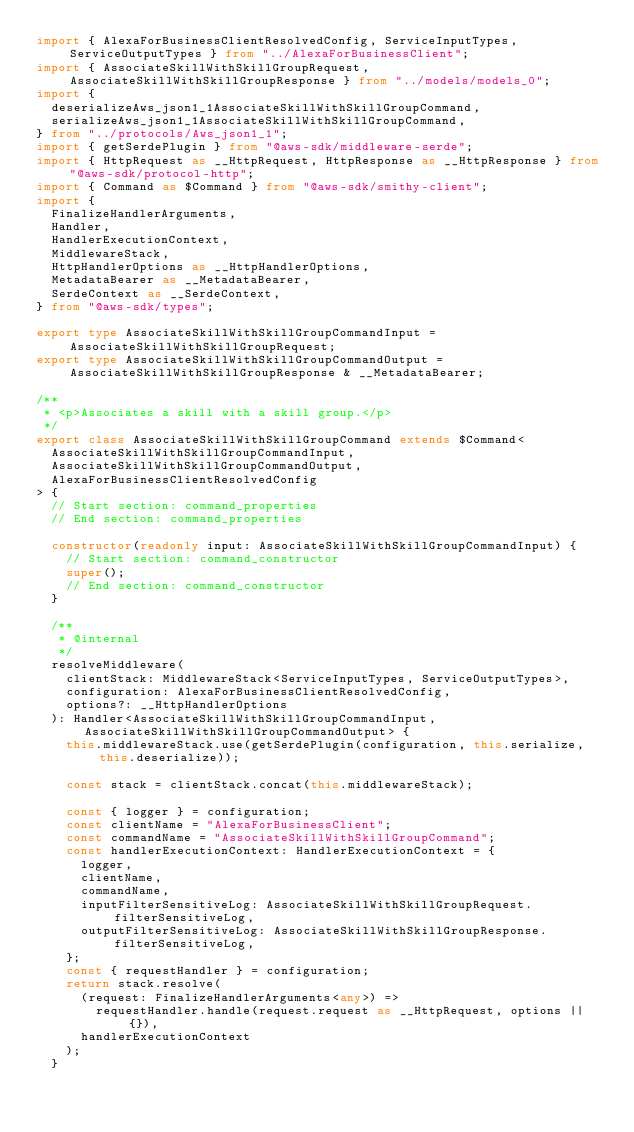Convert code to text. <code><loc_0><loc_0><loc_500><loc_500><_TypeScript_>import { AlexaForBusinessClientResolvedConfig, ServiceInputTypes, ServiceOutputTypes } from "../AlexaForBusinessClient";
import { AssociateSkillWithSkillGroupRequest, AssociateSkillWithSkillGroupResponse } from "../models/models_0";
import {
  deserializeAws_json1_1AssociateSkillWithSkillGroupCommand,
  serializeAws_json1_1AssociateSkillWithSkillGroupCommand,
} from "../protocols/Aws_json1_1";
import { getSerdePlugin } from "@aws-sdk/middleware-serde";
import { HttpRequest as __HttpRequest, HttpResponse as __HttpResponse } from "@aws-sdk/protocol-http";
import { Command as $Command } from "@aws-sdk/smithy-client";
import {
  FinalizeHandlerArguments,
  Handler,
  HandlerExecutionContext,
  MiddlewareStack,
  HttpHandlerOptions as __HttpHandlerOptions,
  MetadataBearer as __MetadataBearer,
  SerdeContext as __SerdeContext,
} from "@aws-sdk/types";

export type AssociateSkillWithSkillGroupCommandInput = AssociateSkillWithSkillGroupRequest;
export type AssociateSkillWithSkillGroupCommandOutput = AssociateSkillWithSkillGroupResponse & __MetadataBearer;

/**
 * <p>Associates a skill with a skill group.</p>
 */
export class AssociateSkillWithSkillGroupCommand extends $Command<
  AssociateSkillWithSkillGroupCommandInput,
  AssociateSkillWithSkillGroupCommandOutput,
  AlexaForBusinessClientResolvedConfig
> {
  // Start section: command_properties
  // End section: command_properties

  constructor(readonly input: AssociateSkillWithSkillGroupCommandInput) {
    // Start section: command_constructor
    super();
    // End section: command_constructor
  }

  /**
   * @internal
   */
  resolveMiddleware(
    clientStack: MiddlewareStack<ServiceInputTypes, ServiceOutputTypes>,
    configuration: AlexaForBusinessClientResolvedConfig,
    options?: __HttpHandlerOptions
  ): Handler<AssociateSkillWithSkillGroupCommandInput, AssociateSkillWithSkillGroupCommandOutput> {
    this.middlewareStack.use(getSerdePlugin(configuration, this.serialize, this.deserialize));

    const stack = clientStack.concat(this.middlewareStack);

    const { logger } = configuration;
    const clientName = "AlexaForBusinessClient";
    const commandName = "AssociateSkillWithSkillGroupCommand";
    const handlerExecutionContext: HandlerExecutionContext = {
      logger,
      clientName,
      commandName,
      inputFilterSensitiveLog: AssociateSkillWithSkillGroupRequest.filterSensitiveLog,
      outputFilterSensitiveLog: AssociateSkillWithSkillGroupResponse.filterSensitiveLog,
    };
    const { requestHandler } = configuration;
    return stack.resolve(
      (request: FinalizeHandlerArguments<any>) =>
        requestHandler.handle(request.request as __HttpRequest, options || {}),
      handlerExecutionContext
    );
  }
</code> 